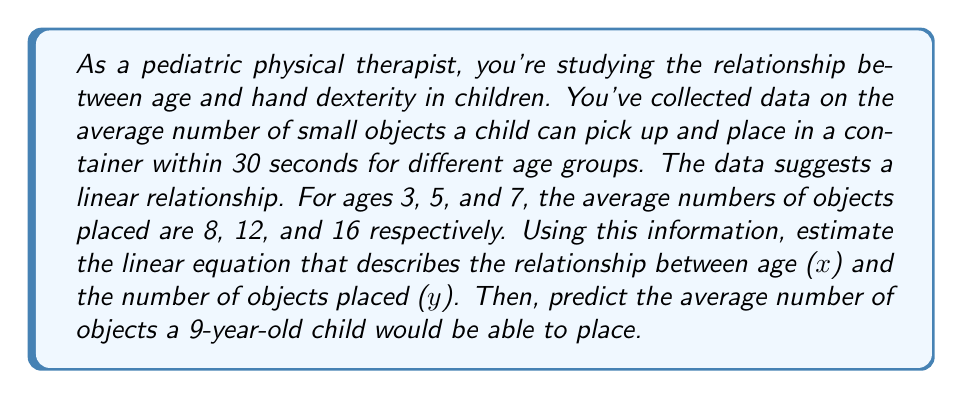Solve this math problem. To solve this problem, we'll use the point-slope form of a linear equation: $y - y_1 = m(x - x_1)$, where $m$ is the slope.

1. Calculate the slope ($m$) using two points:
   $m = \frac{y_2 - y_1}{x_2 - x_1} = \frac{16 - 8}{7 - 3} = \frac{8}{4} = 2$

2. The slope indicates that for each year increase in age, the number of objects placed increases by 2.

3. Use the point (3, 8) and the calculated slope to form the equation:
   $y - 8 = 2(x - 3)$

4. Simplify the equation:
   $y = 2(x - 3) + 8$
   $y = 2x - 6 + 8$
   $y = 2x + 2$

5. To predict the average number of objects a 9-year-old child would place, substitute $x = 9$ into the equation:
   $y = 2(9) + 2 = 18 + 2 = 20$

Therefore, the linear equation is $y = 2x + 2$, and a 9-year-old child would be predicted to place an average of 20 objects in 30 seconds.
Answer: Linear equation: $y = 2x + 2$
Predicted objects for a 9-year-old: 20 